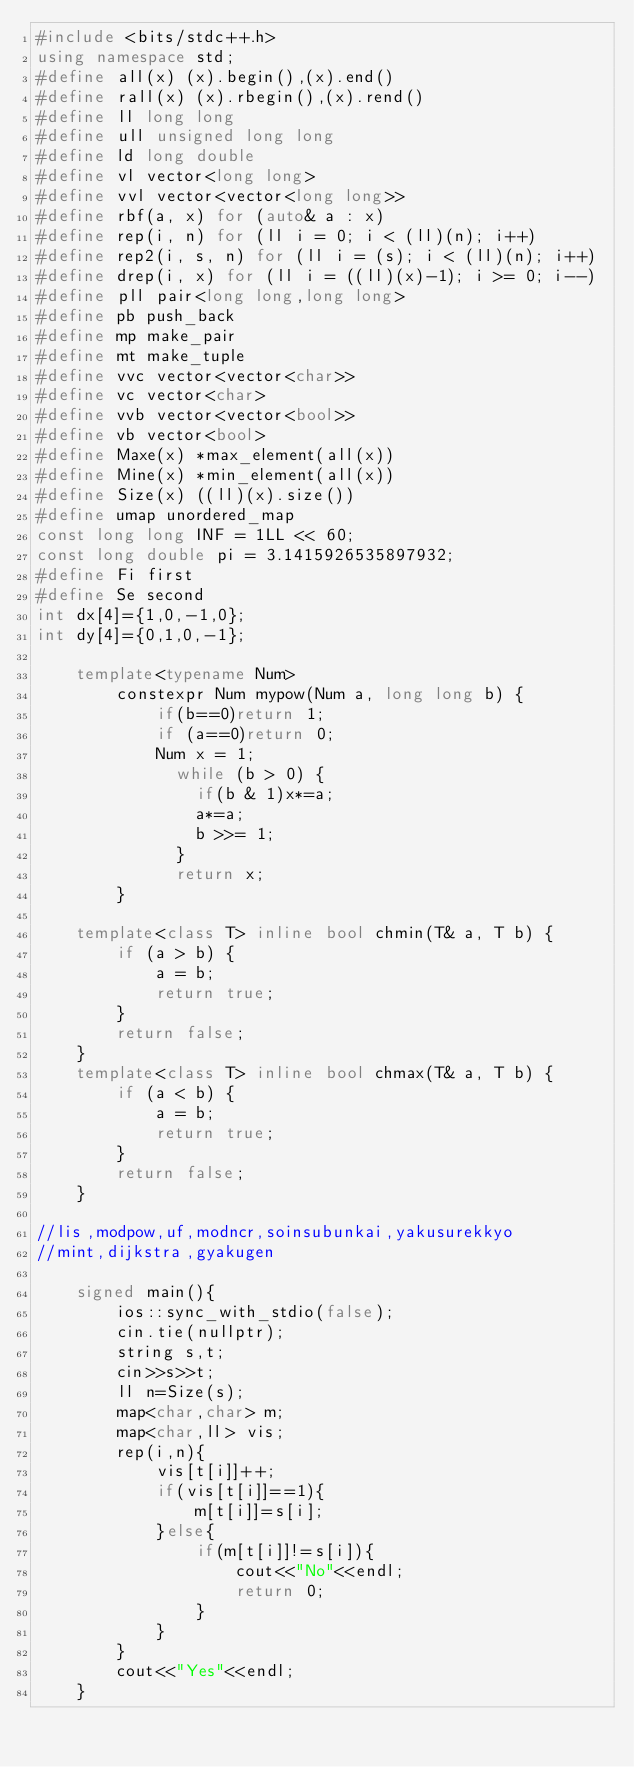<code> <loc_0><loc_0><loc_500><loc_500><_C++_>#include <bits/stdc++.h>
using namespace std;
#define all(x) (x).begin(),(x).end()
#define rall(x) (x).rbegin(),(x).rend()
#define ll long long
#define ull unsigned long long
#define ld long double
#define vl vector<long long>
#define vvl vector<vector<long long>>
#define rbf(a, x) for (auto& a : x)
#define rep(i, n) for (ll i = 0; i < (ll)(n); i++)
#define rep2(i, s, n) for (ll i = (s); i < (ll)(n); i++)
#define drep(i, x) for (ll i = ((ll)(x)-1); i >= 0; i--)
#define pll pair<long long,long long>
#define pb push_back
#define mp make_pair
#define mt make_tuple
#define vvc vector<vector<char>>
#define vc vector<char>
#define vvb vector<vector<bool>>
#define vb vector<bool>
#define Maxe(x) *max_element(all(x))
#define Mine(x) *min_element(all(x))
#define Size(x) ((ll)(x).size())
#define umap unordered_map
const long long INF = 1LL << 60;
const long double pi = 3.1415926535897932;
#define Fi first
#define Se second
int dx[4]={1,0,-1,0};
int dy[4]={0,1,0,-1};

    template<typename Num>
        constexpr Num mypow(Num a, long long b) {
            if(b==0)return 1;
            if (a==0)return 0;
            Num x = 1;
              while (b > 0) {
                if(b & 1)x*=a;
                a*=a;
                b >>= 1;
              }
              return x;
        }

    template<class T> inline bool chmin(T& a, T b) {
        if (a > b) {
            a = b;
            return true;
        }
        return false;
    }
    template<class T> inline bool chmax(T& a, T b) {
        if (a < b) {
            a = b;
            return true;
        }
        return false;
    }

//lis,modpow,uf,modncr,soinsubunkai,yakusurekkyo
//mint,dijkstra,gyakugen

    signed main(){
        ios::sync_with_stdio(false);
        cin.tie(nullptr);
        string s,t;
        cin>>s>>t;
        ll n=Size(s);
        map<char,char> m;
        map<char,ll> vis;
        rep(i,n){
            vis[t[i]]++;
            if(vis[t[i]]==1){
                m[t[i]]=s[i];
            }else{
                if(m[t[i]]!=s[i]){
                    cout<<"No"<<endl;
                    return 0;
                }
            }
        }
        cout<<"Yes"<<endl;
    }</code> 